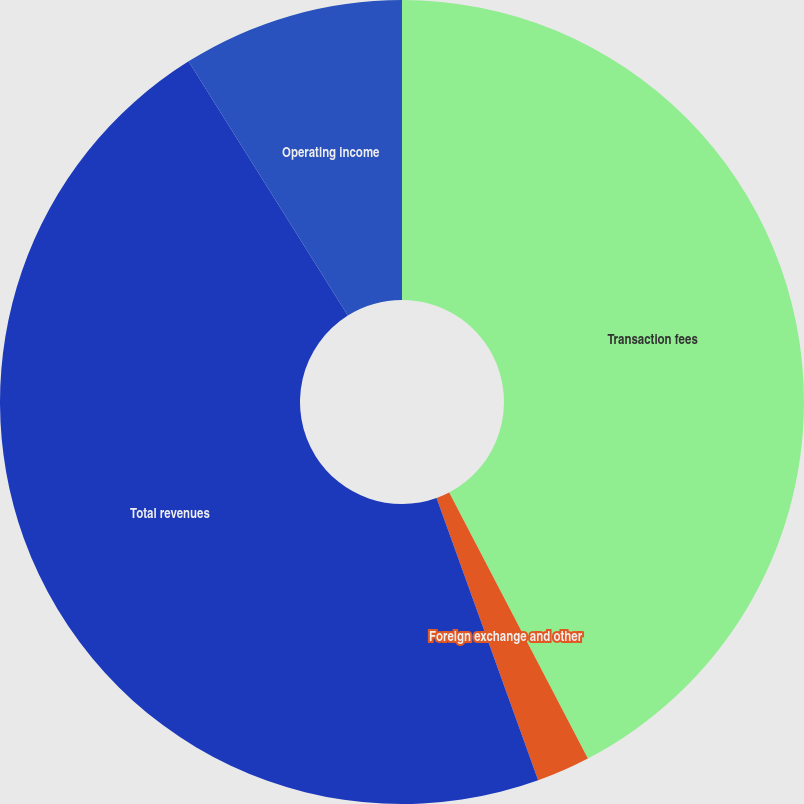Convert chart. <chart><loc_0><loc_0><loc_500><loc_500><pie_chart><fcel>Transaction fees<fcel>Foreign exchange and other<fcel>Total revenues<fcel>Operating income<nl><fcel>42.35%<fcel>2.15%<fcel>46.59%<fcel>8.91%<nl></chart> 